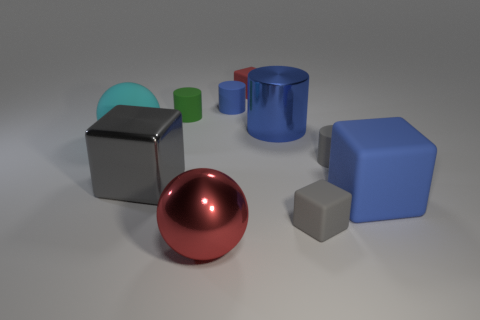How many cubes are both behind the cyan sphere and in front of the small red matte cube?
Your response must be concise. 0. Is the material of the big block that is on the left side of the large blue matte thing the same as the big cyan ball?
Give a very brief answer. No. The large blue thing that is behind the ball that is behind the small cube right of the red matte object is what shape?
Provide a short and direct response. Cylinder. Are there an equal number of tiny blocks that are behind the gray metal object and big red metal spheres to the right of the small red matte cube?
Keep it short and to the point. No. What color is the other ball that is the same size as the shiny ball?
Keep it short and to the point. Cyan. What number of tiny objects are either blue matte objects or red matte things?
Your answer should be very brief. 2. There is a thing that is on the left side of the red metal ball and to the right of the big gray thing; what material is it?
Make the answer very short. Rubber. Does the small gray thing that is to the left of the gray cylinder have the same shape as the metal object right of the small red matte block?
Offer a terse response. No. The small object that is the same color as the big shiny cylinder is what shape?
Provide a short and direct response. Cylinder. How many things are tiny cubes that are behind the rubber sphere or big blue blocks?
Your answer should be very brief. 2. 